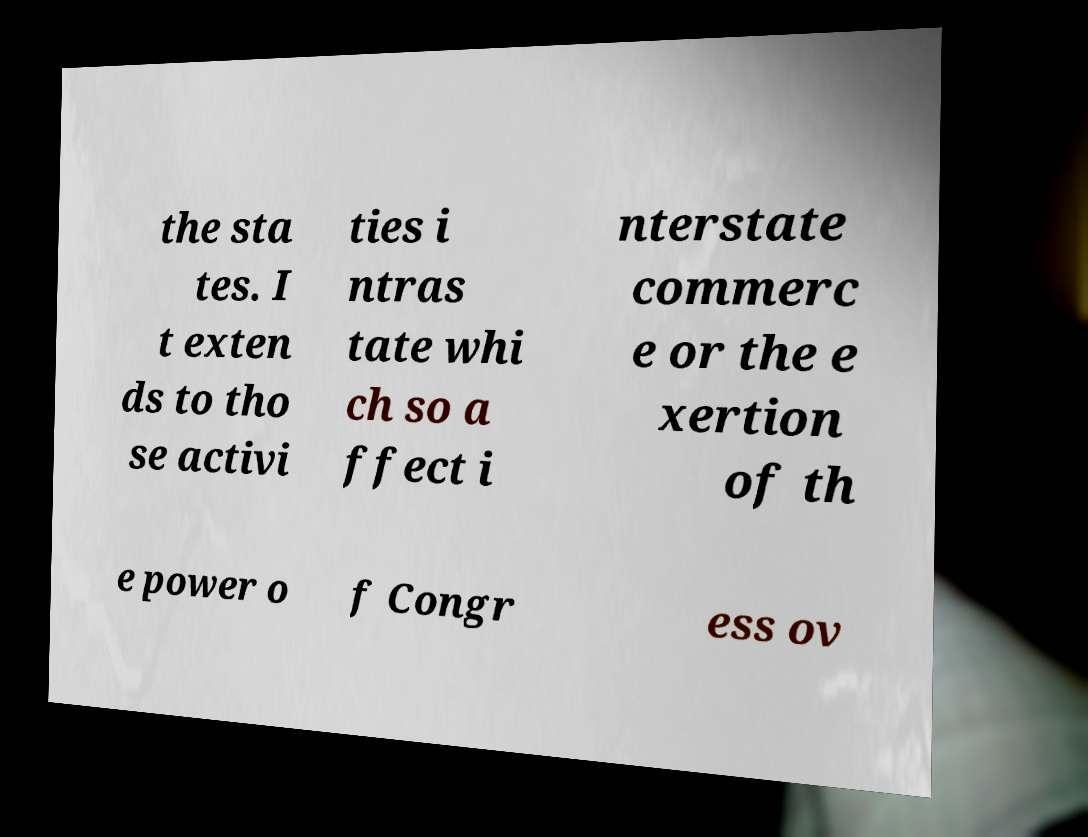Could you assist in decoding the text presented in this image and type it out clearly? the sta tes. I t exten ds to tho se activi ties i ntras tate whi ch so a ffect i nterstate commerc e or the e xertion of th e power o f Congr ess ov 